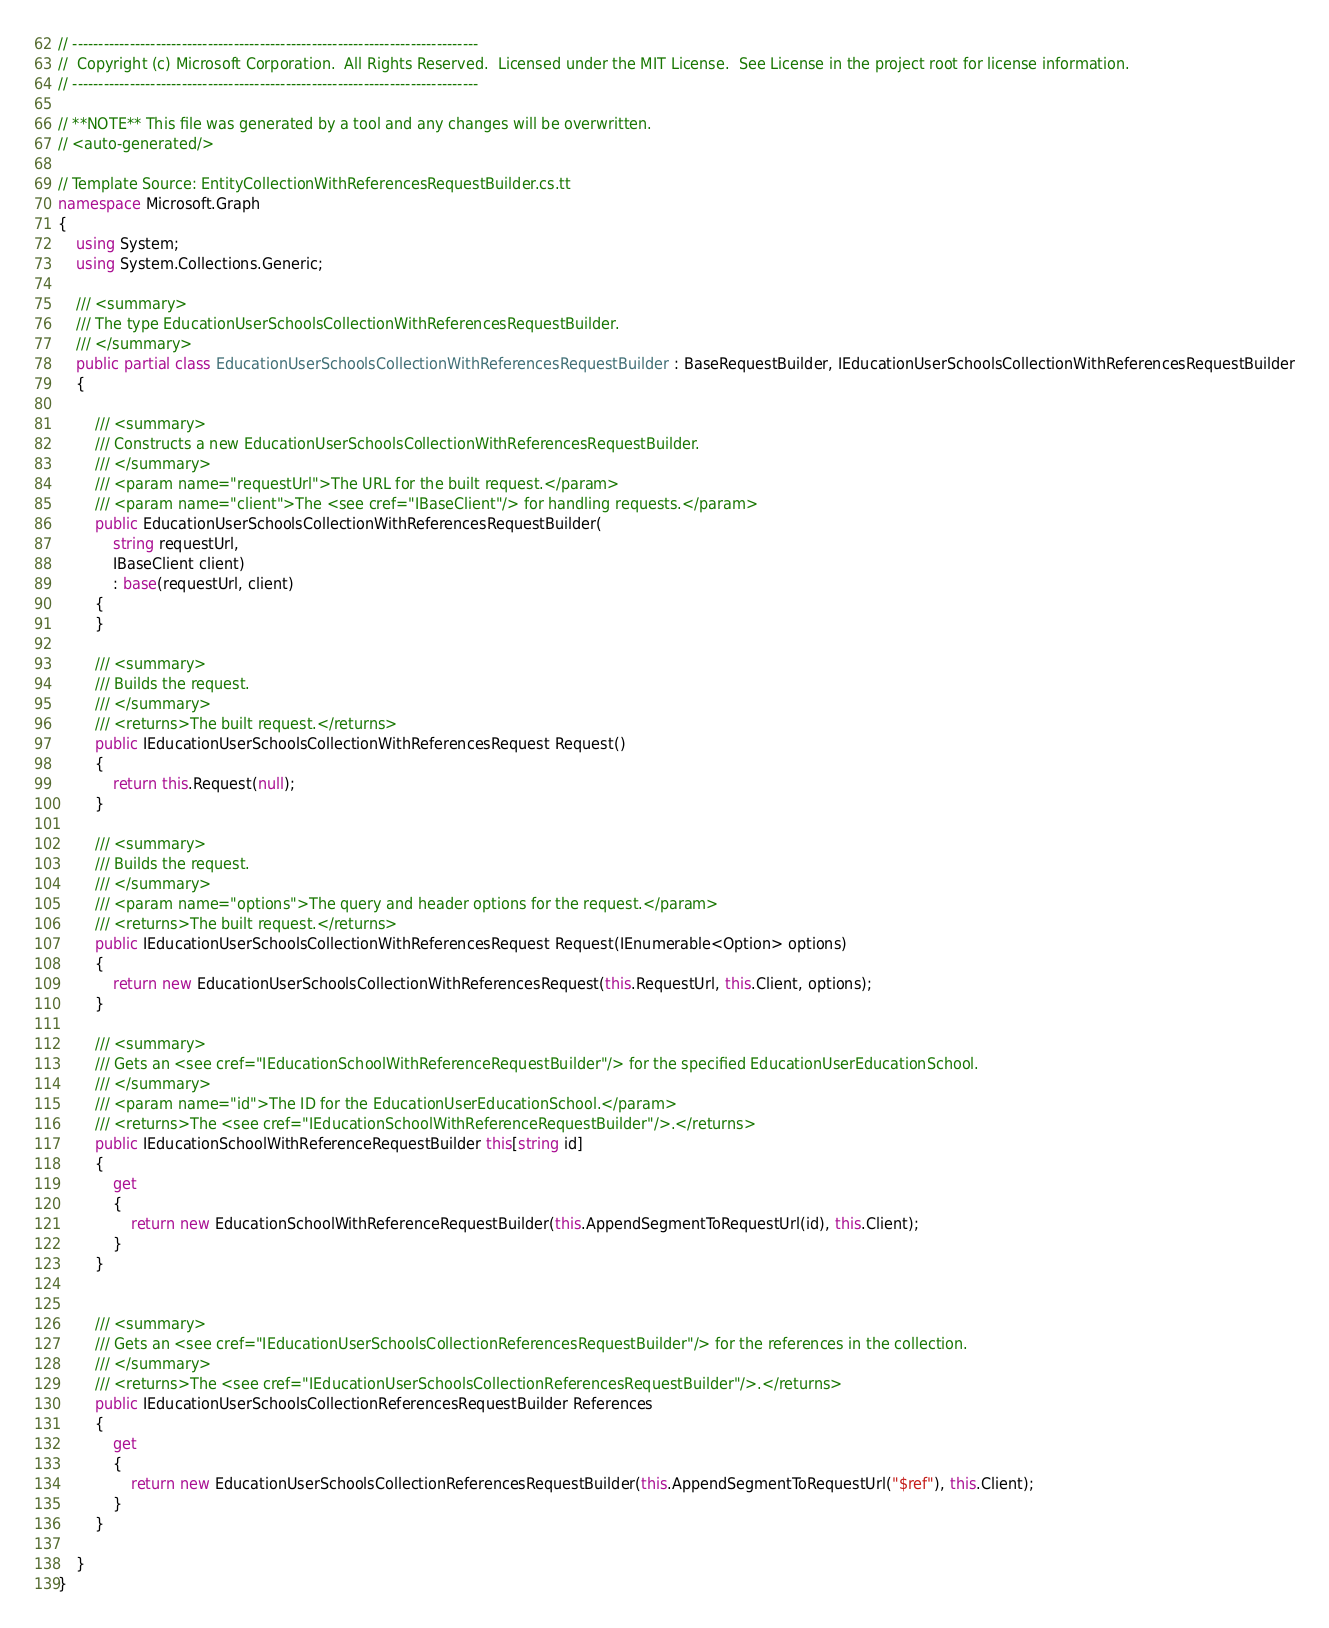Convert code to text. <code><loc_0><loc_0><loc_500><loc_500><_C#_>// ------------------------------------------------------------------------------
//  Copyright (c) Microsoft Corporation.  All Rights Reserved.  Licensed under the MIT License.  See License in the project root for license information.
// ------------------------------------------------------------------------------

// **NOTE** This file was generated by a tool and any changes will be overwritten.
// <auto-generated/>

// Template Source: EntityCollectionWithReferencesRequestBuilder.cs.tt
namespace Microsoft.Graph
{
    using System;
    using System.Collections.Generic;

    /// <summary>
    /// The type EducationUserSchoolsCollectionWithReferencesRequestBuilder.
    /// </summary>
    public partial class EducationUserSchoolsCollectionWithReferencesRequestBuilder : BaseRequestBuilder, IEducationUserSchoolsCollectionWithReferencesRequestBuilder
    {

        /// <summary>
        /// Constructs a new EducationUserSchoolsCollectionWithReferencesRequestBuilder.
        /// </summary>
        /// <param name="requestUrl">The URL for the built request.</param>
        /// <param name="client">The <see cref="IBaseClient"/> for handling requests.</param>
        public EducationUserSchoolsCollectionWithReferencesRequestBuilder(
            string requestUrl,
            IBaseClient client)
            : base(requestUrl, client)
        {
        }

        /// <summary>
        /// Builds the request.
        /// </summary>
        /// <returns>The built request.</returns>
        public IEducationUserSchoolsCollectionWithReferencesRequest Request()
        {
            return this.Request(null);
        }

        /// <summary>
        /// Builds the request.
        /// </summary>
        /// <param name="options">The query and header options for the request.</param>
        /// <returns>The built request.</returns>
        public IEducationUserSchoolsCollectionWithReferencesRequest Request(IEnumerable<Option> options)
        {
            return new EducationUserSchoolsCollectionWithReferencesRequest(this.RequestUrl, this.Client, options);
        }

        /// <summary>
        /// Gets an <see cref="IEducationSchoolWithReferenceRequestBuilder"/> for the specified EducationUserEducationSchool.
        /// </summary>
        /// <param name="id">The ID for the EducationUserEducationSchool.</param>
        /// <returns>The <see cref="IEducationSchoolWithReferenceRequestBuilder"/>.</returns>
        public IEducationSchoolWithReferenceRequestBuilder this[string id]
        {
            get
            {
                return new EducationSchoolWithReferenceRequestBuilder(this.AppendSegmentToRequestUrl(id), this.Client);
            }
        }

        
        /// <summary>
        /// Gets an <see cref="IEducationUserSchoolsCollectionReferencesRequestBuilder"/> for the references in the collection.
        /// </summary>
        /// <returns>The <see cref="IEducationUserSchoolsCollectionReferencesRequestBuilder"/>.</returns>
        public IEducationUserSchoolsCollectionReferencesRequestBuilder References
        {
            get
            {
                return new EducationUserSchoolsCollectionReferencesRequestBuilder(this.AppendSegmentToRequestUrl("$ref"), this.Client);
            }
        }

    }
}
</code> 